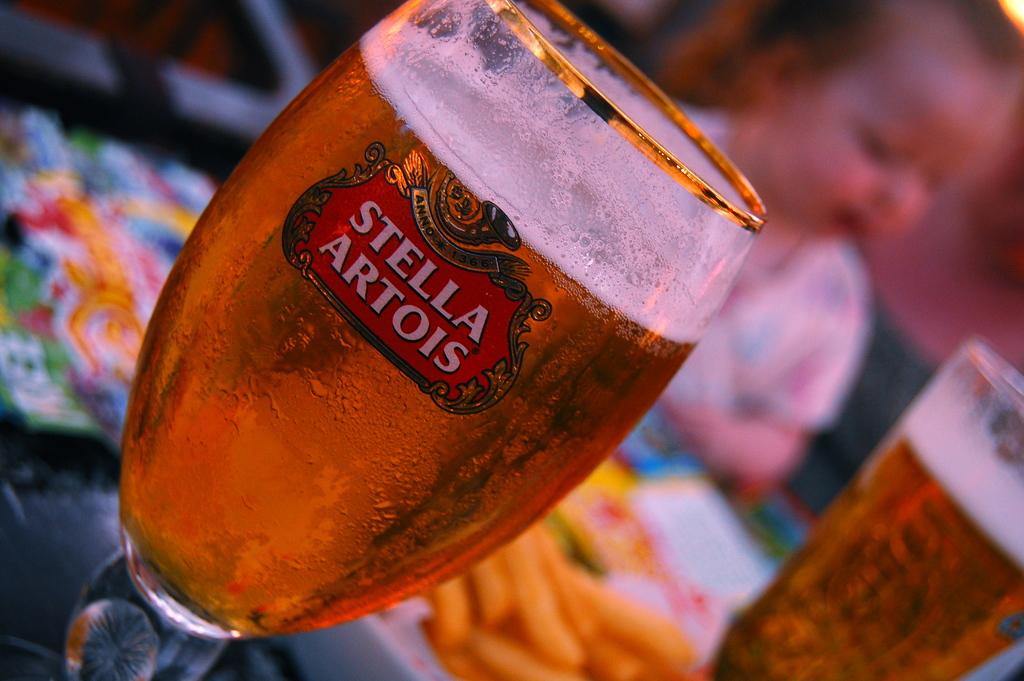What kind of beer is this?
Your answer should be very brief. Stella artois. What numbers are on this glass?
Offer a very short reply. 1366. 